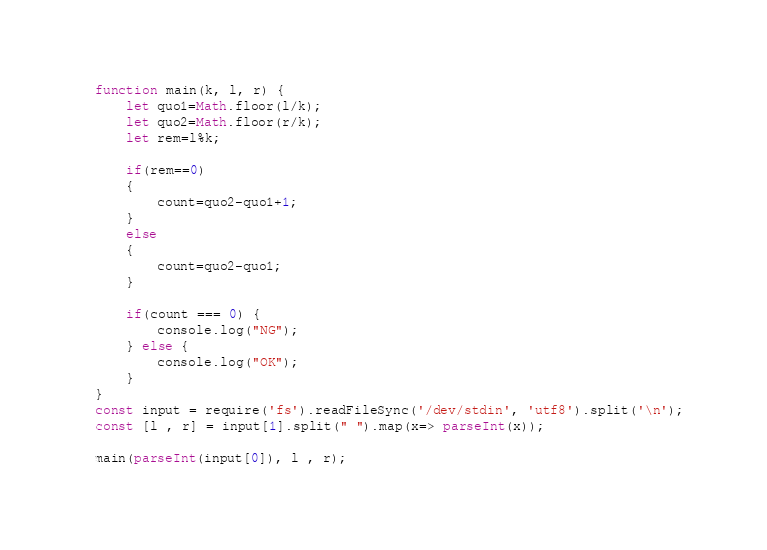Convert code to text. <code><loc_0><loc_0><loc_500><loc_500><_JavaScript_>function main(k, l, r) {
  	let quo1=Math.floor(l/k);
 	let quo2=Math.floor(r/k);
 	let rem=l%k;
 	
  	if(rem==0)
 	{
   		count=quo2-quo1+1;
 	}
 	else
 	{
    	count=quo2-quo1;
  	}

  	if(count === 0) {
    	console.log("NG");
    } else {
    	console.log("OK");
    }
}
const input = require('fs').readFileSync('/dev/stdin', 'utf8').split('\n');
const [l , r] = input[1].split(" ").map(x=> parseInt(x));

main(parseInt(input[0]), l , r);
</code> 